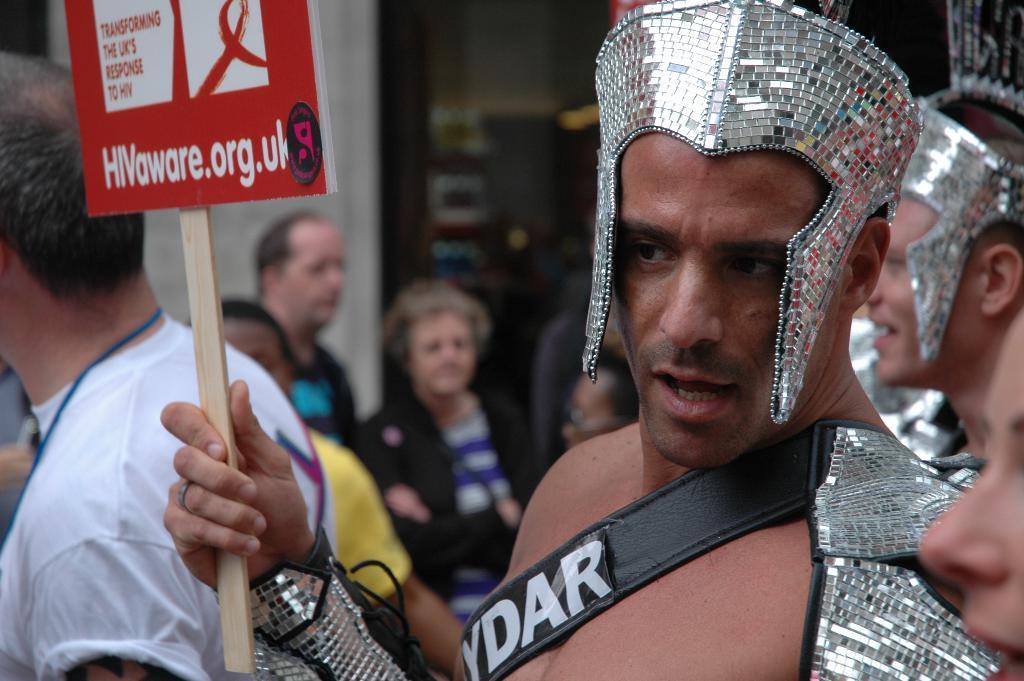How would you summarize this image in a sentence or two? In this picture we can see a man holding a poster with his hand and some people. In the background we can see some objects and it is blurry. 